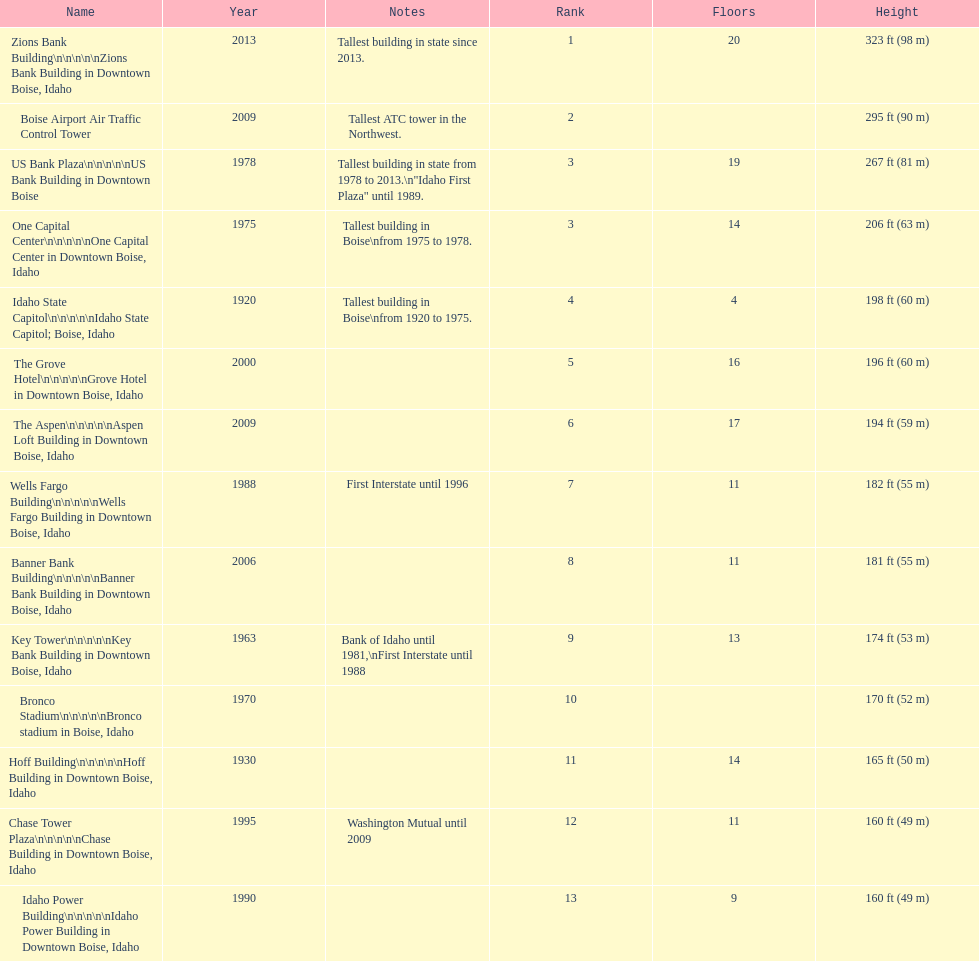What are the number of floors the us bank plaza has? 19. 